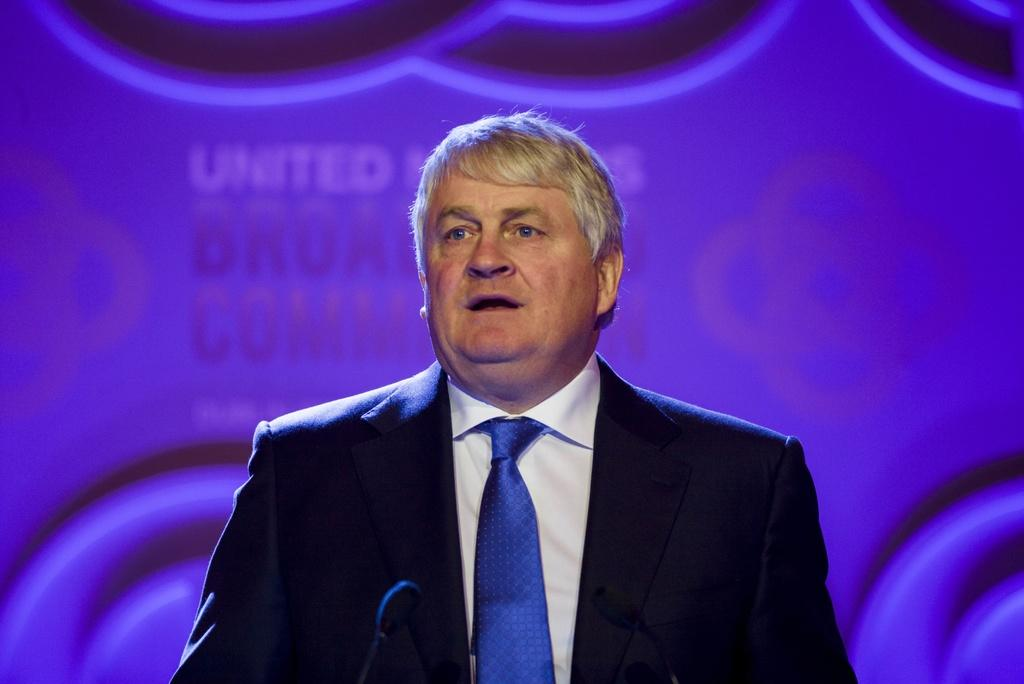What is the main subject in the foreground of the picture? There is a man in the foreground of the picture. What is the man wearing? The man is wearing a black suit and a blue tie. What is the man doing in the picture? The man is talking. What object is in front of the man? There is a microphone in front of the man. What color is the hoarding in the background? The hoarding in the background is violet-colored. Can you read the caption on the stream in the image? There is no stream or caption present in the image. What type of ant can be seen crawling on the man's tie? There are no ants present in the image. 